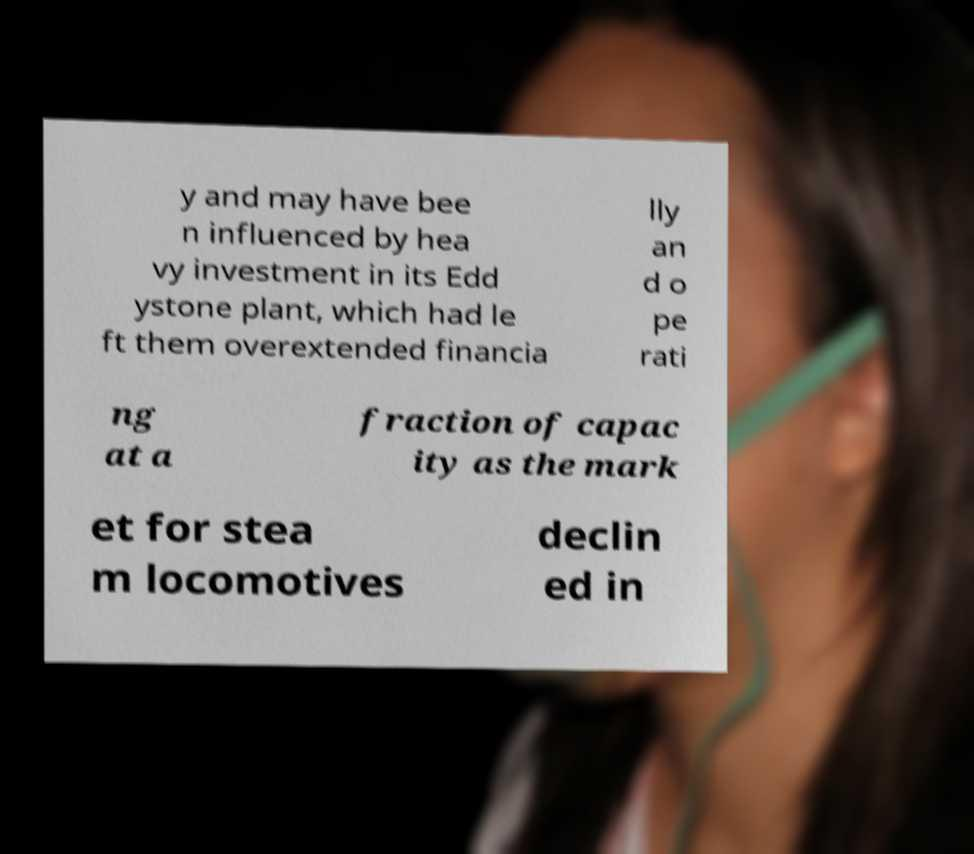Please read and relay the text visible in this image. What does it say? y and may have bee n influenced by hea vy investment in its Edd ystone plant, which had le ft them overextended financia lly an d o pe rati ng at a fraction of capac ity as the mark et for stea m locomotives declin ed in 